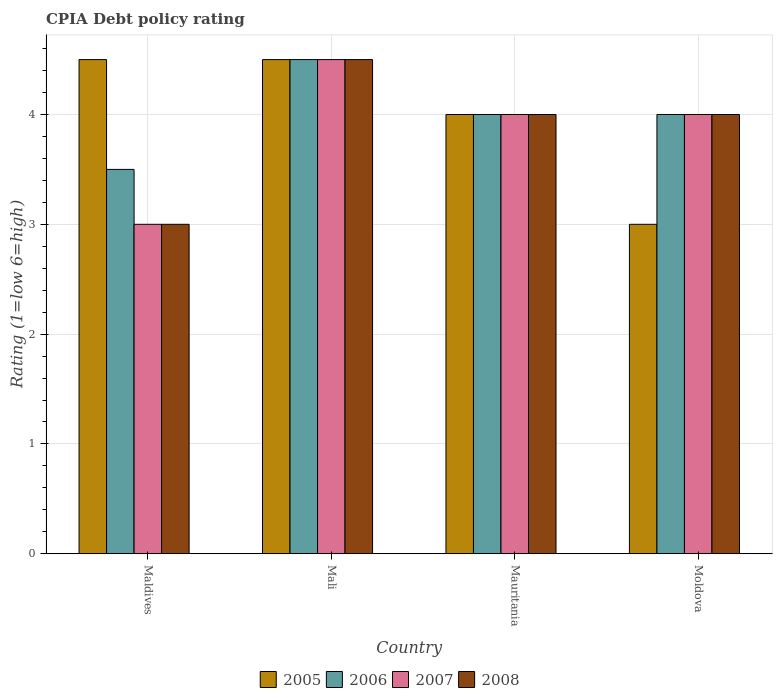How many groups of bars are there?
Your answer should be compact. 4. How many bars are there on the 3rd tick from the left?
Offer a very short reply. 4. What is the label of the 4th group of bars from the left?
Make the answer very short. Moldova. What is the CPIA rating in 2007 in Mali?
Your response must be concise. 4.5. Across all countries, what is the maximum CPIA rating in 2008?
Provide a succinct answer. 4.5. In which country was the CPIA rating in 2006 maximum?
Give a very brief answer. Mali. In which country was the CPIA rating in 2005 minimum?
Make the answer very short. Moldova. What is the total CPIA rating in 2005 in the graph?
Provide a short and direct response. 16. What is the difference between the CPIA rating in 2007 in Mauritania and the CPIA rating in 2008 in Moldova?
Ensure brevity in your answer.  0. What is the average CPIA rating in 2007 per country?
Offer a very short reply. 3.88. What is the difference between the CPIA rating of/in 2006 and CPIA rating of/in 2007 in Maldives?
Give a very brief answer. 0.5. Is the difference between the CPIA rating in 2006 in Mali and Mauritania greater than the difference between the CPIA rating in 2007 in Mali and Mauritania?
Offer a terse response. No. What is the difference between the highest and the second highest CPIA rating in 2006?
Offer a terse response. 0.5. Is it the case that in every country, the sum of the CPIA rating in 2006 and CPIA rating in 2008 is greater than the sum of CPIA rating in 2007 and CPIA rating in 2005?
Ensure brevity in your answer.  No. What does the 1st bar from the left in Moldova represents?
Provide a succinct answer. 2005. Are all the bars in the graph horizontal?
Offer a terse response. No. What is the difference between two consecutive major ticks on the Y-axis?
Your response must be concise. 1. Are the values on the major ticks of Y-axis written in scientific E-notation?
Offer a terse response. No. Does the graph contain grids?
Keep it short and to the point. Yes. Where does the legend appear in the graph?
Your answer should be compact. Bottom center. What is the title of the graph?
Provide a succinct answer. CPIA Debt policy rating. What is the label or title of the X-axis?
Make the answer very short. Country. What is the Rating (1=low 6=high) in 2007 in Maldives?
Keep it short and to the point. 3. What is the Rating (1=low 6=high) in 2008 in Maldives?
Make the answer very short. 3. What is the Rating (1=low 6=high) of 2007 in Mauritania?
Provide a short and direct response. 4. What is the Rating (1=low 6=high) of 2008 in Moldova?
Offer a terse response. 4. Across all countries, what is the maximum Rating (1=low 6=high) of 2005?
Provide a short and direct response. 4.5. Across all countries, what is the minimum Rating (1=low 6=high) in 2005?
Provide a succinct answer. 3. Across all countries, what is the minimum Rating (1=low 6=high) of 2008?
Offer a terse response. 3. What is the total Rating (1=low 6=high) of 2007 in the graph?
Give a very brief answer. 15.5. What is the total Rating (1=low 6=high) of 2008 in the graph?
Provide a succinct answer. 15.5. What is the difference between the Rating (1=low 6=high) in 2006 in Maldives and that in Mali?
Offer a terse response. -1. What is the difference between the Rating (1=low 6=high) of 2008 in Maldives and that in Mali?
Your response must be concise. -1.5. What is the difference between the Rating (1=low 6=high) in 2005 in Maldives and that in Mauritania?
Provide a short and direct response. 0.5. What is the difference between the Rating (1=low 6=high) in 2006 in Maldives and that in Mauritania?
Offer a very short reply. -0.5. What is the difference between the Rating (1=low 6=high) of 2008 in Maldives and that in Mauritania?
Provide a short and direct response. -1. What is the difference between the Rating (1=low 6=high) of 2007 in Maldives and that in Moldova?
Provide a succinct answer. -1. What is the difference between the Rating (1=low 6=high) of 2006 in Mali and that in Mauritania?
Provide a succinct answer. 0.5. What is the difference between the Rating (1=low 6=high) in 2008 in Mali and that in Moldova?
Your response must be concise. 0.5. What is the difference between the Rating (1=low 6=high) of 2005 in Mauritania and that in Moldova?
Your answer should be very brief. 1. What is the difference between the Rating (1=low 6=high) of 2008 in Mauritania and that in Moldova?
Provide a short and direct response. 0. What is the difference between the Rating (1=low 6=high) of 2005 in Maldives and the Rating (1=low 6=high) of 2007 in Mali?
Your answer should be very brief. 0. What is the difference between the Rating (1=low 6=high) in 2006 in Maldives and the Rating (1=low 6=high) in 2007 in Mali?
Provide a short and direct response. -1. What is the difference between the Rating (1=low 6=high) in 2007 in Maldives and the Rating (1=low 6=high) in 2008 in Mali?
Your answer should be compact. -1.5. What is the difference between the Rating (1=low 6=high) in 2005 in Maldives and the Rating (1=low 6=high) in 2007 in Mauritania?
Your answer should be very brief. 0.5. What is the difference between the Rating (1=low 6=high) of 2007 in Maldives and the Rating (1=low 6=high) of 2008 in Mauritania?
Provide a short and direct response. -1. What is the difference between the Rating (1=low 6=high) in 2005 in Maldives and the Rating (1=low 6=high) in 2008 in Moldova?
Offer a terse response. 0.5. What is the difference between the Rating (1=low 6=high) in 2007 in Maldives and the Rating (1=low 6=high) in 2008 in Moldova?
Make the answer very short. -1. What is the difference between the Rating (1=low 6=high) in 2005 in Mali and the Rating (1=low 6=high) in 2007 in Mauritania?
Provide a short and direct response. 0.5. What is the difference between the Rating (1=low 6=high) in 2006 in Mali and the Rating (1=low 6=high) in 2007 in Mauritania?
Your response must be concise. 0.5. What is the difference between the Rating (1=low 6=high) of 2006 in Mali and the Rating (1=low 6=high) of 2008 in Mauritania?
Your answer should be very brief. 0.5. What is the difference between the Rating (1=low 6=high) in 2005 in Mali and the Rating (1=low 6=high) in 2007 in Moldova?
Provide a short and direct response. 0.5. What is the difference between the Rating (1=low 6=high) of 2005 in Mauritania and the Rating (1=low 6=high) of 2006 in Moldova?
Your response must be concise. 0. What is the difference between the Rating (1=low 6=high) of 2005 in Mauritania and the Rating (1=low 6=high) of 2007 in Moldova?
Make the answer very short. 0. What is the difference between the Rating (1=low 6=high) in 2006 in Mauritania and the Rating (1=low 6=high) in 2008 in Moldova?
Provide a succinct answer. 0. What is the average Rating (1=low 6=high) of 2006 per country?
Keep it short and to the point. 4. What is the average Rating (1=low 6=high) in 2007 per country?
Keep it short and to the point. 3.88. What is the average Rating (1=low 6=high) in 2008 per country?
Your answer should be very brief. 3.88. What is the difference between the Rating (1=low 6=high) of 2005 and Rating (1=low 6=high) of 2007 in Maldives?
Offer a very short reply. 1.5. What is the difference between the Rating (1=low 6=high) of 2007 and Rating (1=low 6=high) of 2008 in Maldives?
Make the answer very short. 0. What is the difference between the Rating (1=low 6=high) of 2005 and Rating (1=low 6=high) of 2007 in Mali?
Your response must be concise. 0. What is the difference between the Rating (1=low 6=high) in 2005 and Rating (1=low 6=high) in 2008 in Mali?
Your answer should be compact. 0. What is the difference between the Rating (1=low 6=high) in 2006 and Rating (1=low 6=high) in 2008 in Mali?
Make the answer very short. 0. What is the difference between the Rating (1=low 6=high) of 2007 and Rating (1=low 6=high) of 2008 in Mali?
Offer a very short reply. 0. What is the difference between the Rating (1=low 6=high) of 2005 and Rating (1=low 6=high) of 2006 in Mauritania?
Your answer should be very brief. 0. What is the difference between the Rating (1=low 6=high) of 2005 and Rating (1=low 6=high) of 2008 in Mauritania?
Offer a terse response. 0. What is the difference between the Rating (1=low 6=high) in 2007 and Rating (1=low 6=high) in 2008 in Mauritania?
Offer a terse response. 0. What is the difference between the Rating (1=low 6=high) of 2005 and Rating (1=low 6=high) of 2007 in Moldova?
Keep it short and to the point. -1. What is the difference between the Rating (1=low 6=high) of 2006 and Rating (1=low 6=high) of 2007 in Moldova?
Your answer should be compact. 0. What is the difference between the Rating (1=low 6=high) in 2007 and Rating (1=low 6=high) in 2008 in Moldova?
Ensure brevity in your answer.  0. What is the ratio of the Rating (1=low 6=high) of 2005 in Maldives to that in Mali?
Ensure brevity in your answer.  1. What is the ratio of the Rating (1=low 6=high) of 2006 in Maldives to that in Mali?
Provide a succinct answer. 0.78. What is the ratio of the Rating (1=low 6=high) in 2005 in Maldives to that in Moldova?
Offer a very short reply. 1.5. What is the ratio of the Rating (1=low 6=high) in 2006 in Maldives to that in Moldova?
Your response must be concise. 0.88. What is the ratio of the Rating (1=low 6=high) in 2008 in Maldives to that in Moldova?
Offer a very short reply. 0.75. What is the ratio of the Rating (1=low 6=high) in 2006 in Mali to that in Mauritania?
Make the answer very short. 1.12. What is the ratio of the Rating (1=low 6=high) in 2005 in Mali to that in Moldova?
Ensure brevity in your answer.  1.5. What is the ratio of the Rating (1=low 6=high) in 2007 in Mali to that in Moldova?
Give a very brief answer. 1.12. What is the difference between the highest and the second highest Rating (1=low 6=high) of 2007?
Ensure brevity in your answer.  0.5. What is the difference between the highest and the second highest Rating (1=low 6=high) of 2008?
Offer a terse response. 0.5. What is the difference between the highest and the lowest Rating (1=low 6=high) of 2006?
Give a very brief answer. 1. What is the difference between the highest and the lowest Rating (1=low 6=high) in 2007?
Give a very brief answer. 1.5. What is the difference between the highest and the lowest Rating (1=low 6=high) of 2008?
Offer a very short reply. 1.5. 